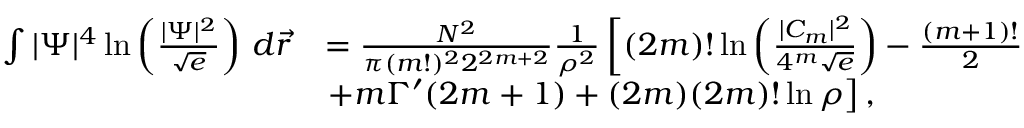Convert formula to latex. <formula><loc_0><loc_0><loc_500><loc_500>\begin{array} { r l } { \int | \Psi | ^ { 4 } \ln \left ( \frac { | \Psi | ^ { 2 } } { \sqrt { e } } \right ) \, d \vec { r } } & { = \frac { N ^ { 2 } } { \pi ( m ! ) ^ { 2 } 2 ^ { 2 m + 2 } } \frac { 1 } { \rho ^ { 2 } } \left [ ( 2 m ) ! \ln \left ( \frac { | C _ { m } | ^ { 2 } } { 4 ^ { m } \sqrt { e } } \right ) - \frac { ( m + 1 ) ! } { 2 } } \\ & { + m \Gamma ^ { \prime } ( 2 m + 1 ) + ( 2 m ) ( 2 m ) ! \ln \rho \right ] , } \end{array}</formula> 